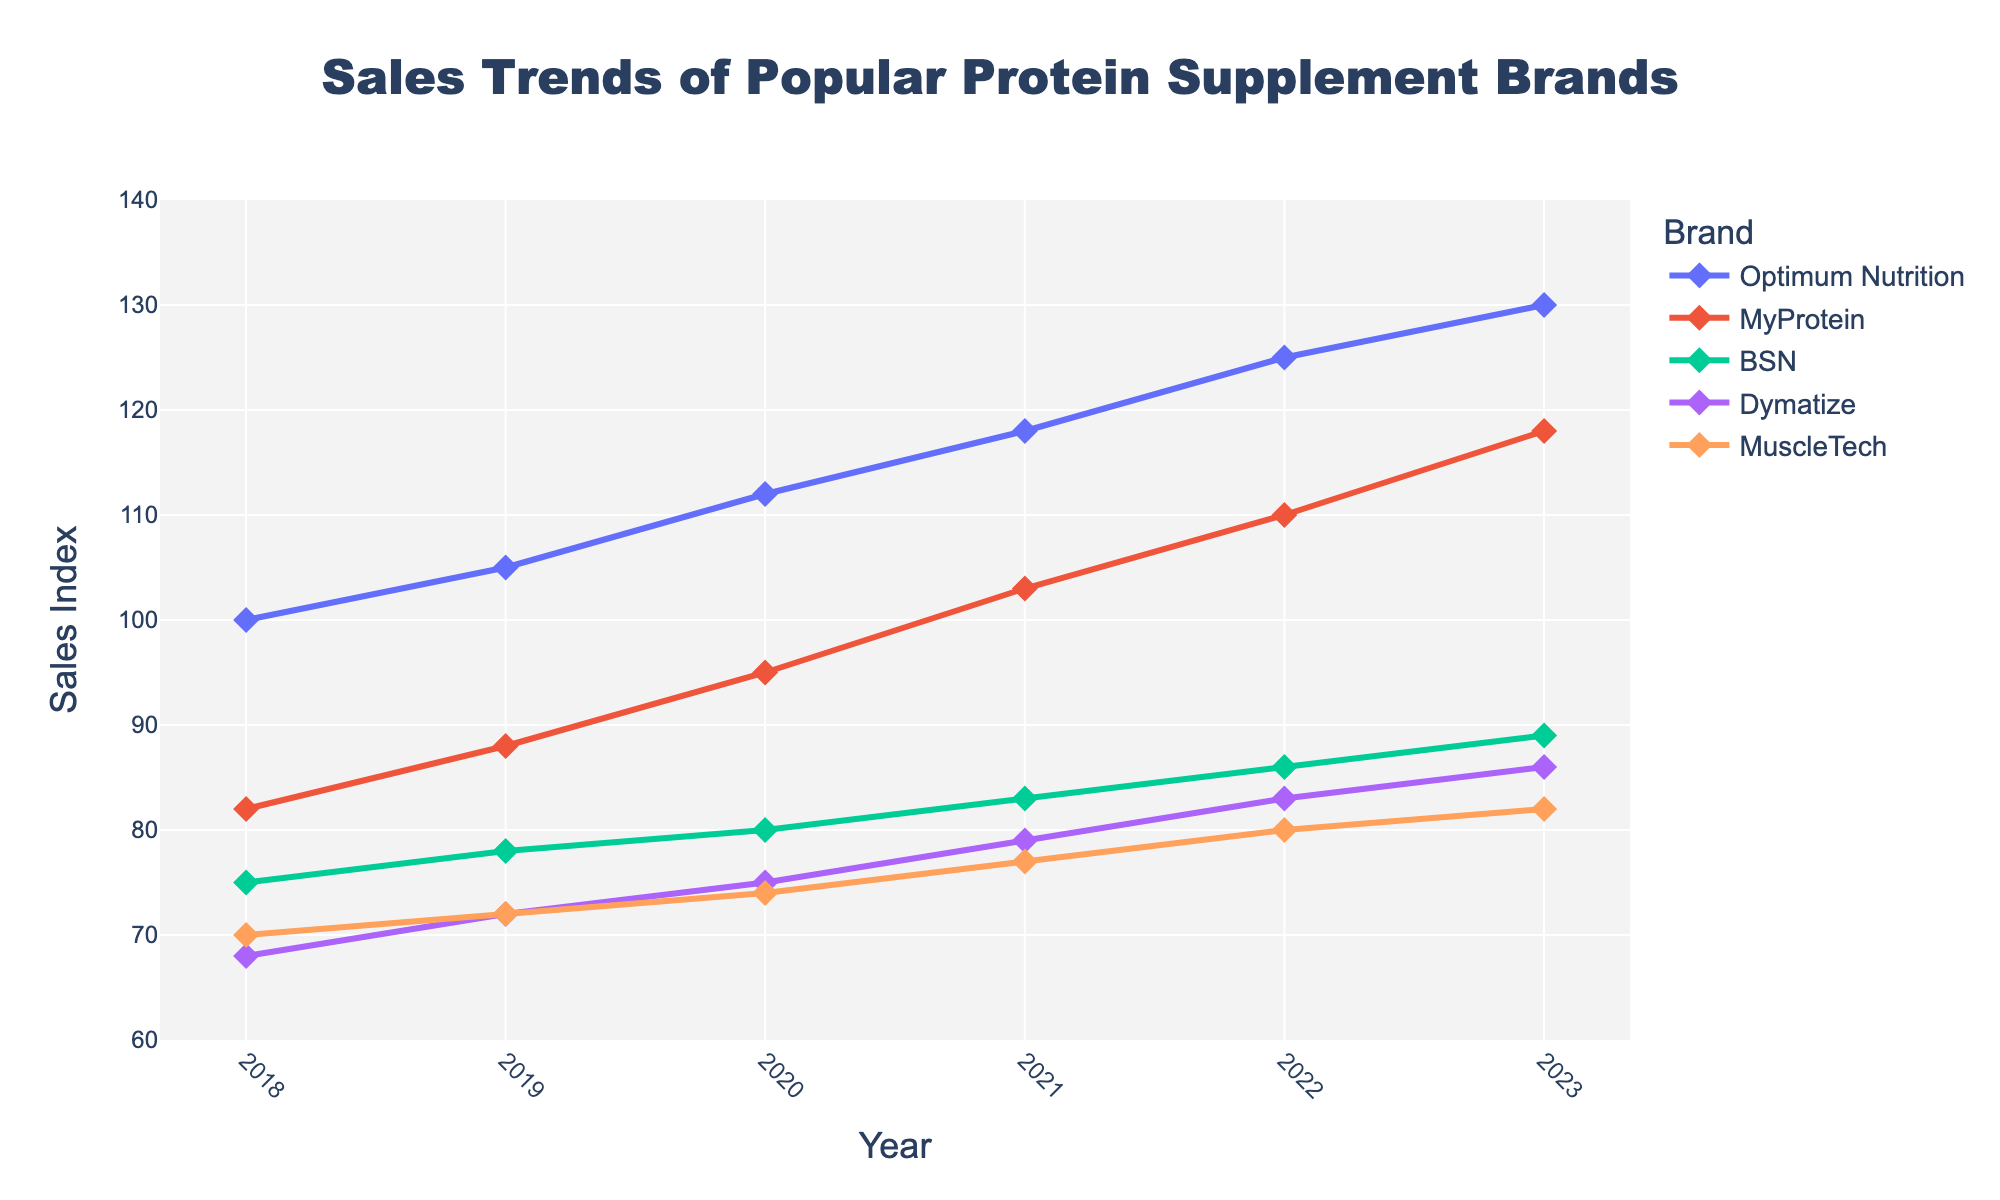What is the trend of Optimum Nutrition's sales over the years? Optimum Nutrition's sales index rose each year, starting from 100 in 2018 and increasing to 130 by 2023.
Answer: Upward Which brand had the highest sales index in 2023? According to the plot, Optimum Nutrition had the highest sales index in 2023 at 130.
Answer: Optimum Nutrition Between 2021 and 2022, which brand showed the largest increase in sales index? By comparing the difference in sales index between 2021 and 2022 for all brands: Optimum Nutrition (+7), MyProtein (+7), BSN (+3), Dymatize (+4), MuscleTech (+3), it is clear that Optimum Nutrition and MyProtein both had the largest increases of 7 units each.
Answer: Optimum Nutrition and MyProtein What is the average sales index of MuscleTech over the entire period? To calculate the average: (70 + 72 + 74 + 77 + 80 + 82) / 6 = 455 / 6 = 75.83
Answer: 75.83 Which brand had the smallest increase in sales index from 2020 to 2021? The increases from 2020 to 2021 are: Optimum Nutrition (+6), MyProtein (+8), BSN (+3), Dymatize (+4), MuscleTech (+3). The smallest increase is for BSN and MuscleTech, each with 3 units.
Answer: BSN and MuscleTech Comparing sales index trends, which brand showed the most consistent year-on-year increase? Optimum Nutrition shows the most consistent year-on-year increase with increments roughly around 5 to 7 units each year.
Answer: Optimum Nutrition In which year did Optimum Nutrition and MyProtein have the smallest difference in their sales indices? The differences for each year are: 2018 (18), 2019 (17), 2020 (17), 2021 (15), 2022 (15), 2023 (12). The smallest difference is in 2023.
Answer: 2023 What was the total sales index for Dymatize from 2018 to 2023? Sum the sales indices: 68 + 72 + 75 + 79 + 83 + 86 = 463
Answer: 463 